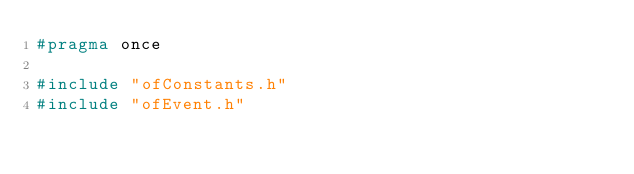Convert code to text. <code><loc_0><loc_0><loc_500><loc_500><_C_>#pragma once

#include "ofConstants.h"
#include "ofEvent.h"
</code> 